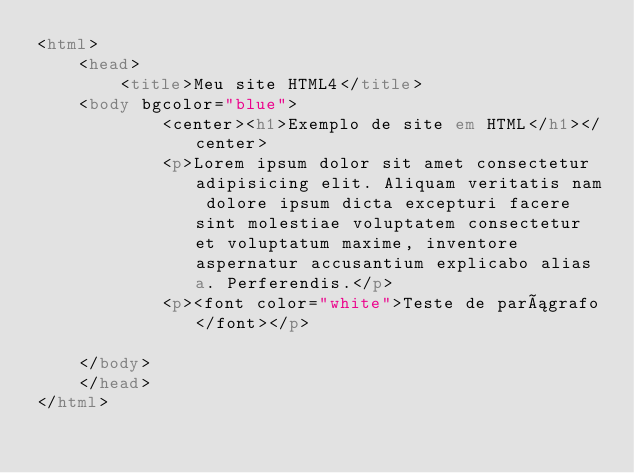<code> <loc_0><loc_0><loc_500><loc_500><_HTML_><html>
    <head>
        <title>Meu site HTML4</title>
    <body bgcolor="blue">
            <center><h1>Exemplo de site em HTML</h1></center>
            <p>Lorem ipsum dolor sit amet consectetur adipisicing elit. Aliquam veritatis nam dolore ipsum dicta excepturi facere sint molestiae voluptatem consectetur et voluptatum maxime, inventore aspernatur accusantium explicabo alias a. Perferendis.</p>
            <p><font color="white">Teste de parágrafo</font></p>

    </body>
    </head>
</html></code> 